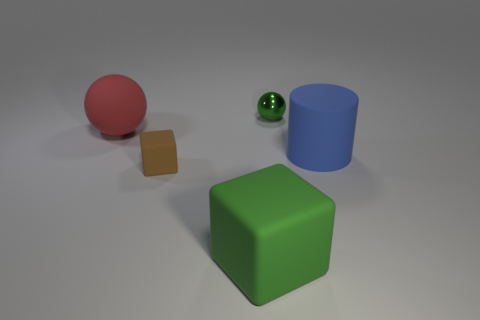Add 4 spheres. How many objects exist? 9 Subtract all spheres. How many objects are left? 3 Add 5 red balls. How many red balls are left? 6 Add 1 blue objects. How many blue objects exist? 2 Subtract 1 green blocks. How many objects are left? 4 Subtract all tiny brown blocks. Subtract all tiny brown objects. How many objects are left? 3 